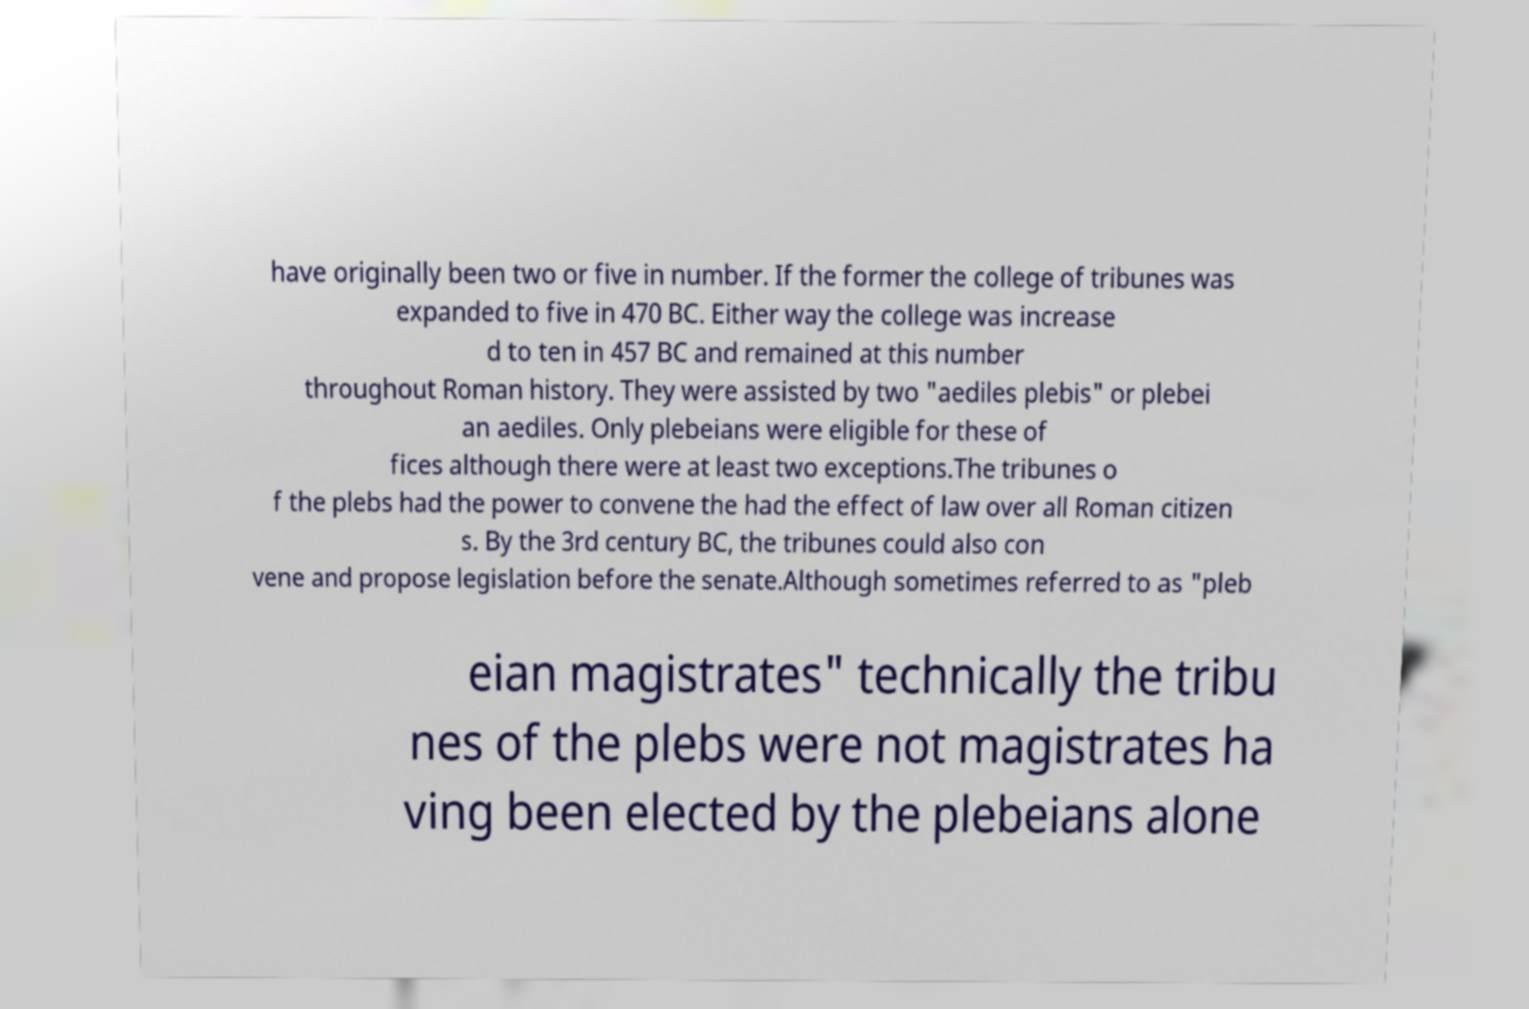Could you assist in decoding the text presented in this image and type it out clearly? have originally been two or five in number. If the former the college of tribunes was expanded to five in 470 BC. Either way the college was increase d to ten in 457 BC and remained at this number throughout Roman history. They were assisted by two "aediles plebis" or plebei an aediles. Only plebeians were eligible for these of fices although there were at least two exceptions.The tribunes o f the plebs had the power to convene the had the effect of law over all Roman citizen s. By the 3rd century BC, the tribunes could also con vene and propose legislation before the senate.Although sometimes referred to as "pleb eian magistrates" technically the tribu nes of the plebs were not magistrates ha ving been elected by the plebeians alone 